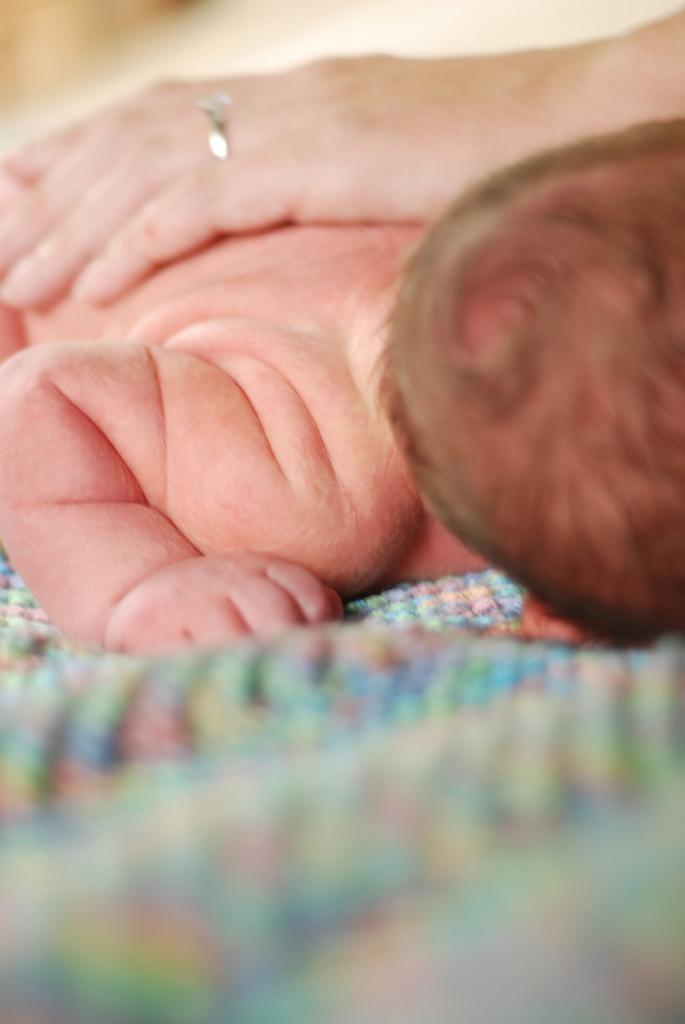Can you describe this image briefly? In this image there is a kid sleeping on the mat. Above the kid there is a hand which has ring to the finger. 